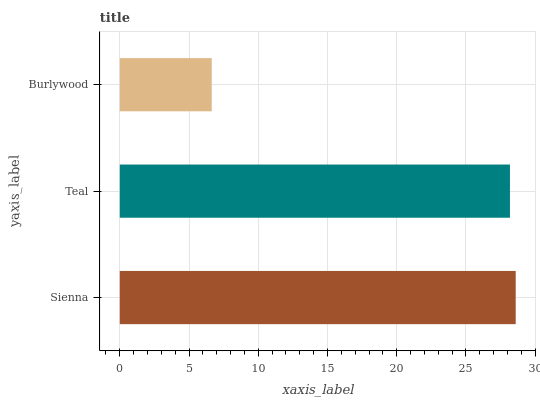Is Burlywood the minimum?
Answer yes or no. Yes. Is Sienna the maximum?
Answer yes or no. Yes. Is Teal the minimum?
Answer yes or no. No. Is Teal the maximum?
Answer yes or no. No. Is Sienna greater than Teal?
Answer yes or no. Yes. Is Teal less than Sienna?
Answer yes or no. Yes. Is Teal greater than Sienna?
Answer yes or no. No. Is Sienna less than Teal?
Answer yes or no. No. Is Teal the high median?
Answer yes or no. Yes. Is Teal the low median?
Answer yes or no. Yes. Is Sienna the high median?
Answer yes or no. No. Is Sienna the low median?
Answer yes or no. No. 